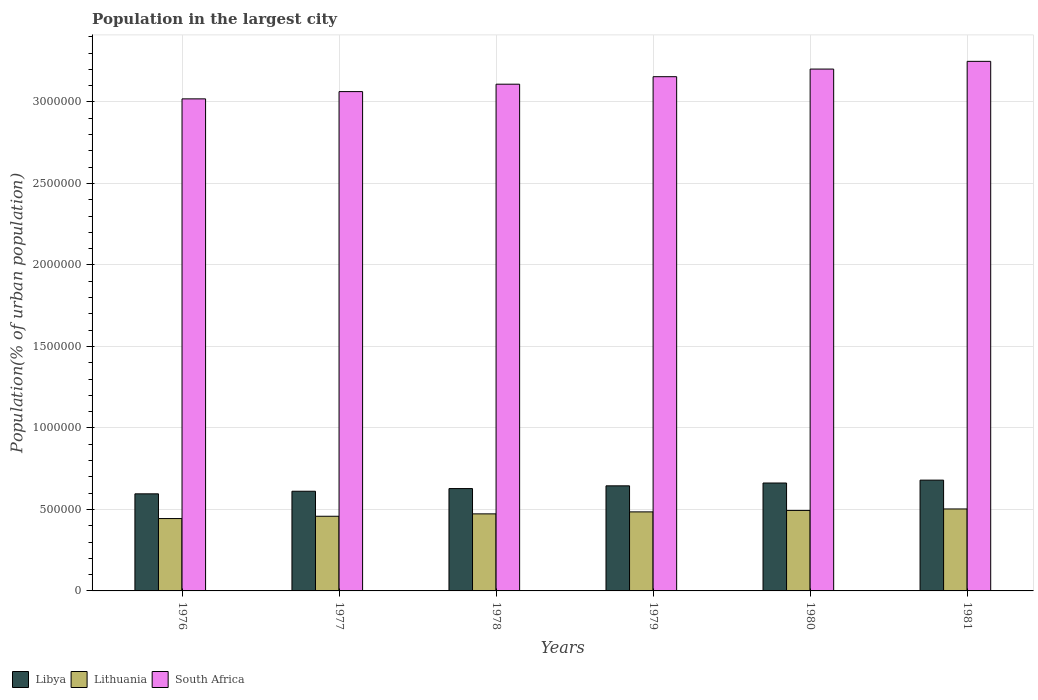In how many cases, is the number of bars for a given year not equal to the number of legend labels?
Provide a succinct answer. 0. What is the population in the largest city in Lithuania in 1979?
Provide a short and direct response. 4.85e+05. Across all years, what is the maximum population in the largest city in South Africa?
Give a very brief answer. 3.25e+06. Across all years, what is the minimum population in the largest city in South Africa?
Provide a succinct answer. 3.02e+06. In which year was the population in the largest city in Lithuania minimum?
Your answer should be very brief. 1976. What is the total population in the largest city in Libya in the graph?
Your answer should be very brief. 3.82e+06. What is the difference between the population in the largest city in Lithuania in 1976 and that in 1981?
Provide a short and direct response. -5.89e+04. What is the difference between the population in the largest city in Libya in 1976 and the population in the largest city in South Africa in 1978?
Ensure brevity in your answer.  -2.51e+06. What is the average population in the largest city in Libya per year?
Ensure brevity in your answer.  6.37e+05. In the year 1981, what is the difference between the population in the largest city in Libya and population in the largest city in South Africa?
Ensure brevity in your answer.  -2.57e+06. In how many years, is the population in the largest city in Lithuania greater than 1100000 %?
Keep it short and to the point. 0. What is the ratio of the population in the largest city in South Africa in 1976 to that in 1981?
Offer a very short reply. 0.93. Is the population in the largest city in Lithuania in 1976 less than that in 1978?
Offer a terse response. Yes. What is the difference between the highest and the second highest population in the largest city in Lithuania?
Make the answer very short. 9045. What is the difference between the highest and the lowest population in the largest city in Lithuania?
Keep it short and to the point. 5.89e+04. Is the sum of the population in the largest city in Lithuania in 1976 and 1979 greater than the maximum population in the largest city in South Africa across all years?
Offer a terse response. No. What does the 2nd bar from the left in 1977 represents?
Provide a short and direct response. Lithuania. What does the 3rd bar from the right in 1981 represents?
Ensure brevity in your answer.  Libya. Are the values on the major ticks of Y-axis written in scientific E-notation?
Your response must be concise. No. Does the graph contain any zero values?
Make the answer very short. No. How many legend labels are there?
Your answer should be compact. 3. What is the title of the graph?
Offer a very short reply. Population in the largest city. What is the label or title of the Y-axis?
Your response must be concise. Population(% of urban population). What is the Population(% of urban population) of Libya in 1976?
Your answer should be very brief. 5.96e+05. What is the Population(% of urban population) in Lithuania in 1976?
Your answer should be compact. 4.44e+05. What is the Population(% of urban population) of South Africa in 1976?
Keep it short and to the point. 3.02e+06. What is the Population(% of urban population) in Libya in 1977?
Offer a terse response. 6.12e+05. What is the Population(% of urban population) in Lithuania in 1977?
Provide a short and direct response. 4.58e+05. What is the Population(% of urban population) in South Africa in 1977?
Your response must be concise. 3.06e+06. What is the Population(% of urban population) of Libya in 1978?
Offer a very short reply. 6.28e+05. What is the Population(% of urban population) of Lithuania in 1978?
Your answer should be very brief. 4.73e+05. What is the Population(% of urban population) of South Africa in 1978?
Offer a terse response. 3.11e+06. What is the Population(% of urban population) in Libya in 1979?
Offer a terse response. 6.45e+05. What is the Population(% of urban population) in Lithuania in 1979?
Make the answer very short. 4.85e+05. What is the Population(% of urban population) in South Africa in 1979?
Your response must be concise. 3.16e+06. What is the Population(% of urban population) of Libya in 1980?
Offer a very short reply. 6.62e+05. What is the Population(% of urban population) in Lithuania in 1980?
Provide a short and direct response. 4.94e+05. What is the Population(% of urban population) of South Africa in 1980?
Offer a terse response. 3.20e+06. What is the Population(% of urban population) of Libya in 1981?
Give a very brief answer. 6.80e+05. What is the Population(% of urban population) of Lithuania in 1981?
Provide a succinct answer. 5.03e+05. What is the Population(% of urban population) in South Africa in 1981?
Provide a short and direct response. 3.25e+06. Across all years, what is the maximum Population(% of urban population) in Libya?
Offer a very short reply. 6.80e+05. Across all years, what is the maximum Population(% of urban population) of Lithuania?
Your response must be concise. 5.03e+05. Across all years, what is the maximum Population(% of urban population) in South Africa?
Your answer should be very brief. 3.25e+06. Across all years, what is the minimum Population(% of urban population) of Libya?
Your answer should be compact. 5.96e+05. Across all years, what is the minimum Population(% of urban population) of Lithuania?
Keep it short and to the point. 4.44e+05. Across all years, what is the minimum Population(% of urban population) of South Africa?
Your answer should be very brief. 3.02e+06. What is the total Population(% of urban population) of Libya in the graph?
Your answer should be very brief. 3.82e+06. What is the total Population(% of urban population) of Lithuania in the graph?
Offer a very short reply. 2.86e+06. What is the total Population(% of urban population) in South Africa in the graph?
Offer a very short reply. 1.88e+07. What is the difference between the Population(% of urban population) of Libya in 1976 and that in 1977?
Your answer should be compact. -1.59e+04. What is the difference between the Population(% of urban population) of Lithuania in 1976 and that in 1977?
Give a very brief answer. -1.42e+04. What is the difference between the Population(% of urban population) in South Africa in 1976 and that in 1977?
Offer a very short reply. -4.46e+04. What is the difference between the Population(% of urban population) in Libya in 1976 and that in 1978?
Ensure brevity in your answer.  -3.23e+04. What is the difference between the Population(% of urban population) of Lithuania in 1976 and that in 1978?
Offer a very short reply. -2.88e+04. What is the difference between the Population(% of urban population) of South Africa in 1976 and that in 1978?
Your answer should be very brief. -9.00e+04. What is the difference between the Population(% of urban population) in Libya in 1976 and that in 1979?
Give a very brief answer. -4.91e+04. What is the difference between the Population(% of urban population) in Lithuania in 1976 and that in 1979?
Provide a succinct answer. -4.10e+04. What is the difference between the Population(% of urban population) of South Africa in 1976 and that in 1979?
Offer a terse response. -1.36e+05. What is the difference between the Population(% of urban population) of Libya in 1976 and that in 1980?
Your response must be concise. -6.64e+04. What is the difference between the Population(% of urban population) of Lithuania in 1976 and that in 1980?
Your answer should be very brief. -4.99e+04. What is the difference between the Population(% of urban population) in South Africa in 1976 and that in 1980?
Ensure brevity in your answer.  -1.83e+05. What is the difference between the Population(% of urban population) of Libya in 1976 and that in 1981?
Make the answer very short. -8.41e+04. What is the difference between the Population(% of urban population) of Lithuania in 1976 and that in 1981?
Give a very brief answer. -5.89e+04. What is the difference between the Population(% of urban population) in South Africa in 1976 and that in 1981?
Provide a succinct answer. -2.30e+05. What is the difference between the Population(% of urban population) of Libya in 1977 and that in 1978?
Keep it short and to the point. -1.64e+04. What is the difference between the Population(% of urban population) of Lithuania in 1977 and that in 1978?
Offer a very short reply. -1.46e+04. What is the difference between the Population(% of urban population) of South Africa in 1977 and that in 1978?
Your response must be concise. -4.54e+04. What is the difference between the Population(% of urban population) of Libya in 1977 and that in 1979?
Your answer should be very brief. -3.32e+04. What is the difference between the Population(% of urban population) of Lithuania in 1977 and that in 1979?
Your answer should be very brief. -2.68e+04. What is the difference between the Population(% of urban population) of South Africa in 1977 and that in 1979?
Your answer should be compact. -9.14e+04. What is the difference between the Population(% of urban population) in Libya in 1977 and that in 1980?
Provide a succinct answer. -5.05e+04. What is the difference between the Population(% of urban population) in Lithuania in 1977 and that in 1980?
Offer a very short reply. -3.57e+04. What is the difference between the Population(% of urban population) of South Africa in 1977 and that in 1980?
Your answer should be compact. -1.38e+05. What is the difference between the Population(% of urban population) in Libya in 1977 and that in 1981?
Provide a succinct answer. -6.82e+04. What is the difference between the Population(% of urban population) in Lithuania in 1977 and that in 1981?
Offer a very short reply. -4.48e+04. What is the difference between the Population(% of urban population) in South Africa in 1977 and that in 1981?
Ensure brevity in your answer.  -1.86e+05. What is the difference between the Population(% of urban population) of Libya in 1978 and that in 1979?
Your answer should be compact. -1.68e+04. What is the difference between the Population(% of urban population) in Lithuania in 1978 and that in 1979?
Your answer should be very brief. -1.22e+04. What is the difference between the Population(% of urban population) of South Africa in 1978 and that in 1979?
Your response must be concise. -4.60e+04. What is the difference between the Population(% of urban population) in Libya in 1978 and that in 1980?
Your answer should be compact. -3.41e+04. What is the difference between the Population(% of urban population) in Lithuania in 1978 and that in 1980?
Keep it short and to the point. -2.11e+04. What is the difference between the Population(% of urban population) in South Africa in 1978 and that in 1980?
Offer a very short reply. -9.28e+04. What is the difference between the Population(% of urban population) in Libya in 1978 and that in 1981?
Offer a terse response. -5.18e+04. What is the difference between the Population(% of urban population) in Lithuania in 1978 and that in 1981?
Keep it short and to the point. -3.01e+04. What is the difference between the Population(% of urban population) in South Africa in 1978 and that in 1981?
Make the answer very short. -1.40e+05. What is the difference between the Population(% of urban population) in Libya in 1979 and that in 1980?
Give a very brief answer. -1.73e+04. What is the difference between the Population(% of urban population) of Lithuania in 1979 and that in 1980?
Offer a terse response. -8906. What is the difference between the Population(% of urban population) in South Africa in 1979 and that in 1980?
Provide a short and direct response. -4.68e+04. What is the difference between the Population(% of urban population) in Libya in 1979 and that in 1981?
Your response must be concise. -3.50e+04. What is the difference between the Population(% of urban population) in Lithuania in 1979 and that in 1981?
Your answer should be very brief. -1.80e+04. What is the difference between the Population(% of urban population) of South Africa in 1979 and that in 1981?
Provide a succinct answer. -9.41e+04. What is the difference between the Population(% of urban population) of Libya in 1980 and that in 1981?
Offer a terse response. -1.77e+04. What is the difference between the Population(% of urban population) of Lithuania in 1980 and that in 1981?
Your answer should be compact. -9045. What is the difference between the Population(% of urban population) of South Africa in 1980 and that in 1981?
Your answer should be compact. -4.74e+04. What is the difference between the Population(% of urban population) of Libya in 1976 and the Population(% of urban population) of Lithuania in 1977?
Offer a very short reply. 1.38e+05. What is the difference between the Population(% of urban population) of Libya in 1976 and the Population(% of urban population) of South Africa in 1977?
Provide a succinct answer. -2.47e+06. What is the difference between the Population(% of urban population) in Lithuania in 1976 and the Population(% of urban population) in South Africa in 1977?
Your response must be concise. -2.62e+06. What is the difference between the Population(% of urban population) in Libya in 1976 and the Population(% of urban population) in Lithuania in 1978?
Ensure brevity in your answer.  1.23e+05. What is the difference between the Population(% of urban population) in Libya in 1976 and the Population(% of urban population) in South Africa in 1978?
Your answer should be very brief. -2.51e+06. What is the difference between the Population(% of urban population) of Lithuania in 1976 and the Population(% of urban population) of South Africa in 1978?
Ensure brevity in your answer.  -2.67e+06. What is the difference between the Population(% of urban population) of Libya in 1976 and the Population(% of urban population) of Lithuania in 1979?
Your response must be concise. 1.11e+05. What is the difference between the Population(% of urban population) of Libya in 1976 and the Population(% of urban population) of South Africa in 1979?
Make the answer very short. -2.56e+06. What is the difference between the Population(% of urban population) of Lithuania in 1976 and the Population(% of urban population) of South Africa in 1979?
Your response must be concise. -2.71e+06. What is the difference between the Population(% of urban population) of Libya in 1976 and the Population(% of urban population) of Lithuania in 1980?
Offer a terse response. 1.02e+05. What is the difference between the Population(% of urban population) in Libya in 1976 and the Population(% of urban population) in South Africa in 1980?
Give a very brief answer. -2.61e+06. What is the difference between the Population(% of urban population) of Lithuania in 1976 and the Population(% of urban population) of South Africa in 1980?
Your answer should be very brief. -2.76e+06. What is the difference between the Population(% of urban population) in Libya in 1976 and the Population(% of urban population) in Lithuania in 1981?
Ensure brevity in your answer.  9.28e+04. What is the difference between the Population(% of urban population) of Libya in 1976 and the Population(% of urban population) of South Africa in 1981?
Provide a succinct answer. -2.65e+06. What is the difference between the Population(% of urban population) of Lithuania in 1976 and the Population(% of urban population) of South Africa in 1981?
Provide a short and direct response. -2.81e+06. What is the difference between the Population(% of urban population) of Libya in 1977 and the Population(% of urban population) of Lithuania in 1978?
Offer a terse response. 1.39e+05. What is the difference between the Population(% of urban population) in Libya in 1977 and the Population(% of urban population) in South Africa in 1978?
Keep it short and to the point. -2.50e+06. What is the difference between the Population(% of urban population) in Lithuania in 1977 and the Population(% of urban population) in South Africa in 1978?
Ensure brevity in your answer.  -2.65e+06. What is the difference between the Population(% of urban population) in Libya in 1977 and the Population(% of urban population) in Lithuania in 1979?
Offer a very short reply. 1.27e+05. What is the difference between the Population(% of urban population) in Libya in 1977 and the Population(% of urban population) in South Africa in 1979?
Your response must be concise. -2.54e+06. What is the difference between the Population(% of urban population) in Lithuania in 1977 and the Population(% of urban population) in South Africa in 1979?
Your answer should be very brief. -2.70e+06. What is the difference between the Population(% of urban population) of Libya in 1977 and the Population(% of urban population) of Lithuania in 1980?
Your answer should be very brief. 1.18e+05. What is the difference between the Population(% of urban population) of Libya in 1977 and the Population(% of urban population) of South Africa in 1980?
Make the answer very short. -2.59e+06. What is the difference between the Population(% of urban population) of Lithuania in 1977 and the Population(% of urban population) of South Africa in 1980?
Keep it short and to the point. -2.74e+06. What is the difference between the Population(% of urban population) of Libya in 1977 and the Population(% of urban population) of Lithuania in 1981?
Provide a short and direct response. 1.09e+05. What is the difference between the Population(% of urban population) of Libya in 1977 and the Population(% of urban population) of South Africa in 1981?
Offer a terse response. -2.64e+06. What is the difference between the Population(% of urban population) of Lithuania in 1977 and the Population(% of urban population) of South Africa in 1981?
Offer a terse response. -2.79e+06. What is the difference between the Population(% of urban population) in Libya in 1978 and the Population(% of urban population) in Lithuania in 1979?
Ensure brevity in your answer.  1.43e+05. What is the difference between the Population(% of urban population) of Libya in 1978 and the Population(% of urban population) of South Africa in 1979?
Provide a succinct answer. -2.53e+06. What is the difference between the Population(% of urban population) in Lithuania in 1978 and the Population(% of urban population) in South Africa in 1979?
Ensure brevity in your answer.  -2.68e+06. What is the difference between the Population(% of urban population) of Libya in 1978 and the Population(% of urban population) of Lithuania in 1980?
Provide a short and direct response. 1.34e+05. What is the difference between the Population(% of urban population) of Libya in 1978 and the Population(% of urban population) of South Africa in 1980?
Offer a very short reply. -2.57e+06. What is the difference between the Population(% of urban population) in Lithuania in 1978 and the Population(% of urban population) in South Africa in 1980?
Make the answer very short. -2.73e+06. What is the difference between the Population(% of urban population) of Libya in 1978 and the Population(% of urban population) of Lithuania in 1981?
Provide a succinct answer. 1.25e+05. What is the difference between the Population(% of urban population) in Libya in 1978 and the Population(% of urban population) in South Africa in 1981?
Offer a very short reply. -2.62e+06. What is the difference between the Population(% of urban population) of Lithuania in 1978 and the Population(% of urban population) of South Africa in 1981?
Keep it short and to the point. -2.78e+06. What is the difference between the Population(% of urban population) of Libya in 1979 and the Population(% of urban population) of Lithuania in 1980?
Keep it short and to the point. 1.51e+05. What is the difference between the Population(% of urban population) of Libya in 1979 and the Population(% of urban population) of South Africa in 1980?
Your answer should be very brief. -2.56e+06. What is the difference between the Population(% of urban population) of Lithuania in 1979 and the Population(% of urban population) of South Africa in 1980?
Provide a short and direct response. -2.72e+06. What is the difference between the Population(% of urban population) of Libya in 1979 and the Population(% of urban population) of Lithuania in 1981?
Give a very brief answer. 1.42e+05. What is the difference between the Population(% of urban population) of Libya in 1979 and the Population(% of urban population) of South Africa in 1981?
Make the answer very short. -2.60e+06. What is the difference between the Population(% of urban population) in Lithuania in 1979 and the Population(% of urban population) in South Africa in 1981?
Provide a short and direct response. -2.76e+06. What is the difference between the Population(% of urban population) of Libya in 1980 and the Population(% of urban population) of Lithuania in 1981?
Provide a short and direct response. 1.59e+05. What is the difference between the Population(% of urban population) in Libya in 1980 and the Population(% of urban population) in South Africa in 1981?
Your answer should be compact. -2.59e+06. What is the difference between the Population(% of urban population) of Lithuania in 1980 and the Population(% of urban population) of South Africa in 1981?
Keep it short and to the point. -2.76e+06. What is the average Population(% of urban population) of Libya per year?
Make the answer very short. 6.37e+05. What is the average Population(% of urban population) of Lithuania per year?
Give a very brief answer. 4.76e+05. What is the average Population(% of urban population) of South Africa per year?
Provide a short and direct response. 3.13e+06. In the year 1976, what is the difference between the Population(% of urban population) in Libya and Population(% of urban population) in Lithuania?
Give a very brief answer. 1.52e+05. In the year 1976, what is the difference between the Population(% of urban population) in Libya and Population(% of urban population) in South Africa?
Ensure brevity in your answer.  -2.42e+06. In the year 1976, what is the difference between the Population(% of urban population) of Lithuania and Population(% of urban population) of South Africa?
Ensure brevity in your answer.  -2.58e+06. In the year 1977, what is the difference between the Population(% of urban population) of Libya and Population(% of urban population) of Lithuania?
Provide a short and direct response. 1.53e+05. In the year 1977, what is the difference between the Population(% of urban population) in Libya and Population(% of urban population) in South Africa?
Offer a terse response. -2.45e+06. In the year 1977, what is the difference between the Population(% of urban population) of Lithuania and Population(% of urban population) of South Africa?
Your answer should be very brief. -2.61e+06. In the year 1978, what is the difference between the Population(% of urban population) in Libya and Population(% of urban population) in Lithuania?
Provide a short and direct response. 1.55e+05. In the year 1978, what is the difference between the Population(% of urban population) of Libya and Population(% of urban population) of South Africa?
Provide a short and direct response. -2.48e+06. In the year 1978, what is the difference between the Population(% of urban population) of Lithuania and Population(% of urban population) of South Africa?
Provide a short and direct response. -2.64e+06. In the year 1979, what is the difference between the Population(% of urban population) in Libya and Population(% of urban population) in Lithuania?
Your response must be concise. 1.60e+05. In the year 1979, what is the difference between the Population(% of urban population) of Libya and Population(% of urban population) of South Africa?
Ensure brevity in your answer.  -2.51e+06. In the year 1979, what is the difference between the Population(% of urban population) of Lithuania and Population(% of urban population) of South Africa?
Provide a succinct answer. -2.67e+06. In the year 1980, what is the difference between the Population(% of urban population) of Libya and Population(% of urban population) of Lithuania?
Provide a short and direct response. 1.68e+05. In the year 1980, what is the difference between the Population(% of urban population) in Libya and Population(% of urban population) in South Africa?
Give a very brief answer. -2.54e+06. In the year 1980, what is the difference between the Population(% of urban population) in Lithuania and Population(% of urban population) in South Africa?
Keep it short and to the point. -2.71e+06. In the year 1981, what is the difference between the Population(% of urban population) in Libya and Population(% of urban population) in Lithuania?
Give a very brief answer. 1.77e+05. In the year 1981, what is the difference between the Population(% of urban population) in Libya and Population(% of urban population) in South Africa?
Offer a terse response. -2.57e+06. In the year 1981, what is the difference between the Population(% of urban population) of Lithuania and Population(% of urban population) of South Africa?
Your answer should be compact. -2.75e+06. What is the ratio of the Population(% of urban population) of Libya in 1976 to that in 1977?
Keep it short and to the point. 0.97. What is the ratio of the Population(% of urban population) in Lithuania in 1976 to that in 1977?
Your answer should be very brief. 0.97. What is the ratio of the Population(% of urban population) of South Africa in 1976 to that in 1977?
Provide a short and direct response. 0.99. What is the ratio of the Population(% of urban population) in Libya in 1976 to that in 1978?
Offer a very short reply. 0.95. What is the ratio of the Population(% of urban population) in Lithuania in 1976 to that in 1978?
Your response must be concise. 0.94. What is the ratio of the Population(% of urban population) of South Africa in 1976 to that in 1978?
Your answer should be compact. 0.97. What is the ratio of the Population(% of urban population) in Libya in 1976 to that in 1979?
Give a very brief answer. 0.92. What is the ratio of the Population(% of urban population) in Lithuania in 1976 to that in 1979?
Make the answer very short. 0.92. What is the ratio of the Population(% of urban population) of South Africa in 1976 to that in 1979?
Your response must be concise. 0.96. What is the ratio of the Population(% of urban population) in Libya in 1976 to that in 1980?
Give a very brief answer. 0.9. What is the ratio of the Population(% of urban population) in Lithuania in 1976 to that in 1980?
Give a very brief answer. 0.9. What is the ratio of the Population(% of urban population) in South Africa in 1976 to that in 1980?
Give a very brief answer. 0.94. What is the ratio of the Population(% of urban population) of Libya in 1976 to that in 1981?
Provide a succinct answer. 0.88. What is the ratio of the Population(% of urban population) of Lithuania in 1976 to that in 1981?
Give a very brief answer. 0.88. What is the ratio of the Population(% of urban population) in South Africa in 1976 to that in 1981?
Give a very brief answer. 0.93. What is the ratio of the Population(% of urban population) in Libya in 1977 to that in 1978?
Offer a very short reply. 0.97. What is the ratio of the Population(% of urban population) of South Africa in 1977 to that in 1978?
Ensure brevity in your answer.  0.99. What is the ratio of the Population(% of urban population) in Libya in 1977 to that in 1979?
Ensure brevity in your answer.  0.95. What is the ratio of the Population(% of urban population) in Lithuania in 1977 to that in 1979?
Your answer should be compact. 0.94. What is the ratio of the Population(% of urban population) in South Africa in 1977 to that in 1979?
Your response must be concise. 0.97. What is the ratio of the Population(% of urban population) of Libya in 1977 to that in 1980?
Keep it short and to the point. 0.92. What is the ratio of the Population(% of urban population) of Lithuania in 1977 to that in 1980?
Your answer should be very brief. 0.93. What is the ratio of the Population(% of urban population) of South Africa in 1977 to that in 1980?
Provide a succinct answer. 0.96. What is the ratio of the Population(% of urban population) of Libya in 1977 to that in 1981?
Your answer should be compact. 0.9. What is the ratio of the Population(% of urban population) in Lithuania in 1977 to that in 1981?
Offer a very short reply. 0.91. What is the ratio of the Population(% of urban population) in South Africa in 1977 to that in 1981?
Ensure brevity in your answer.  0.94. What is the ratio of the Population(% of urban population) in Libya in 1978 to that in 1979?
Offer a very short reply. 0.97. What is the ratio of the Population(% of urban population) in Lithuania in 1978 to that in 1979?
Provide a succinct answer. 0.97. What is the ratio of the Population(% of urban population) in South Africa in 1978 to that in 1979?
Make the answer very short. 0.99. What is the ratio of the Population(% of urban population) in Libya in 1978 to that in 1980?
Your answer should be very brief. 0.95. What is the ratio of the Population(% of urban population) in Lithuania in 1978 to that in 1980?
Keep it short and to the point. 0.96. What is the ratio of the Population(% of urban population) in Libya in 1978 to that in 1981?
Make the answer very short. 0.92. What is the ratio of the Population(% of urban population) of Lithuania in 1978 to that in 1981?
Ensure brevity in your answer.  0.94. What is the ratio of the Population(% of urban population) in South Africa in 1978 to that in 1981?
Make the answer very short. 0.96. What is the ratio of the Population(% of urban population) of Libya in 1979 to that in 1980?
Make the answer very short. 0.97. What is the ratio of the Population(% of urban population) in Lithuania in 1979 to that in 1980?
Keep it short and to the point. 0.98. What is the ratio of the Population(% of urban population) in South Africa in 1979 to that in 1980?
Offer a very short reply. 0.99. What is the ratio of the Population(% of urban population) in Libya in 1979 to that in 1981?
Make the answer very short. 0.95. What is the ratio of the Population(% of urban population) in Libya in 1980 to that in 1981?
Keep it short and to the point. 0.97. What is the ratio of the Population(% of urban population) of South Africa in 1980 to that in 1981?
Your answer should be compact. 0.99. What is the difference between the highest and the second highest Population(% of urban population) of Libya?
Offer a very short reply. 1.77e+04. What is the difference between the highest and the second highest Population(% of urban population) of Lithuania?
Offer a very short reply. 9045. What is the difference between the highest and the second highest Population(% of urban population) in South Africa?
Ensure brevity in your answer.  4.74e+04. What is the difference between the highest and the lowest Population(% of urban population) of Libya?
Your answer should be compact. 8.41e+04. What is the difference between the highest and the lowest Population(% of urban population) in Lithuania?
Ensure brevity in your answer.  5.89e+04. What is the difference between the highest and the lowest Population(% of urban population) in South Africa?
Give a very brief answer. 2.30e+05. 